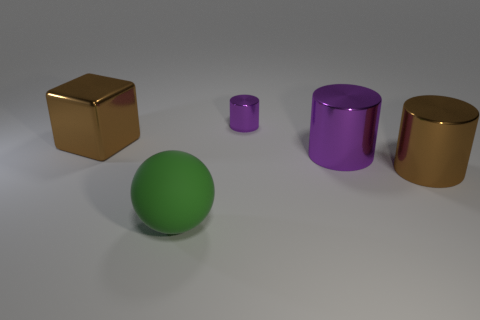Subtract all purple cylinders. How many cylinders are left? 1 Subtract all gray blocks. How many purple cylinders are left? 2 Subtract all brown cylinders. How many cylinders are left? 2 Add 5 big green matte spheres. How many objects exist? 10 Subtract all green cylinders. Subtract all red balls. How many cylinders are left? 3 Subtract all cylinders. How many objects are left? 2 Subtract all big metal spheres. Subtract all cylinders. How many objects are left? 2 Add 2 cubes. How many cubes are left? 3 Add 1 small brown metallic cubes. How many small brown metallic cubes exist? 1 Subtract 0 cyan cylinders. How many objects are left? 5 